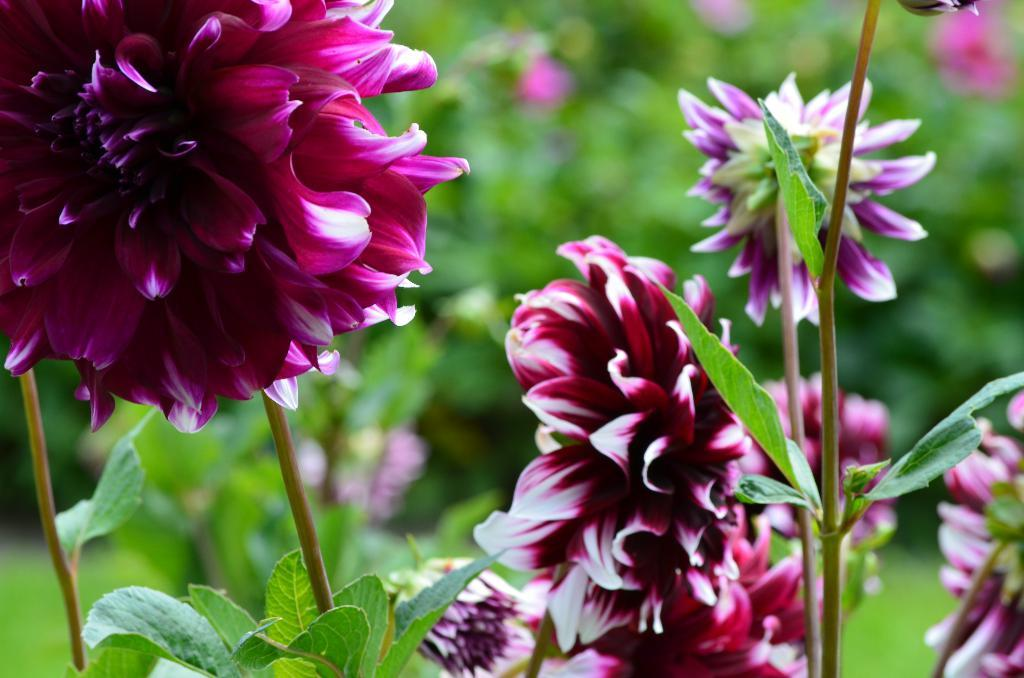What types of living organisms can be seen in the image? Plants and flowers are visible in the image. Can you describe the appearance of the flowers? The flowers are colorful and appear to be in bloom. What is the condition of the background in the image? The background of the image is blurred. What type of creature can be seen slithering through the flowers in the image? There are no creatures visible in the image, and no slithering can be observed. 